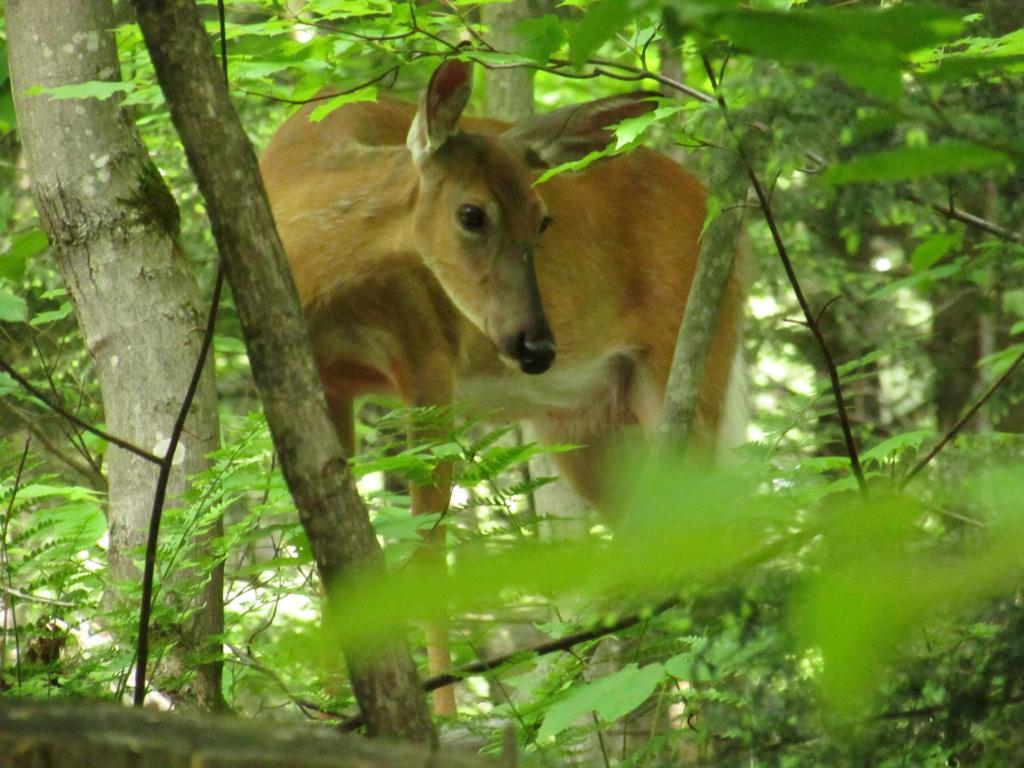What animal is present in the image? There is a brown deer in the image. Where is the deer located in the image? The deer is in the middle of the forest. What type of vegetation can be seen in the background of the image? There are many green trees and plants in the background of the image. How many boys are balancing on the deer in the image? There are no boys present in the image, and the deer is not being used for balancing. 